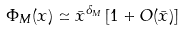<formula> <loc_0><loc_0><loc_500><loc_500>\Phi _ { M } ( x ) \simeq { \bar { x } } ^ { \delta _ { M } } \left [ 1 + O ( { \bar { x } } ) \right ]</formula> 